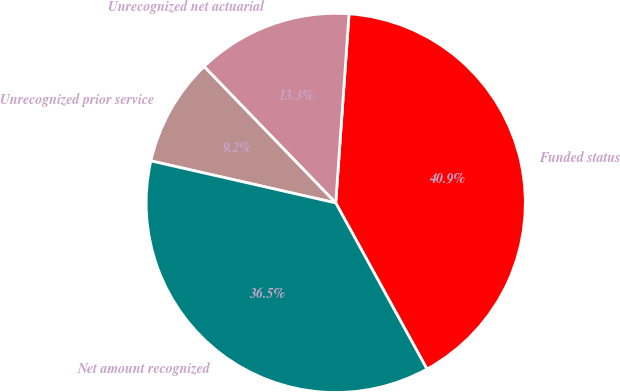<chart> <loc_0><loc_0><loc_500><loc_500><pie_chart><fcel>Funded status<fcel>Unrecognized net actuarial<fcel>Unrecognized prior service<fcel>Net amount recognized<nl><fcel>40.89%<fcel>13.34%<fcel>9.22%<fcel>36.55%<nl></chart> 